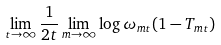<formula> <loc_0><loc_0><loc_500><loc_500>\lim _ { t \rightarrow \infty } \frac { 1 } { 2 t } \lim _ { m \rightarrow \infty } \log \omega _ { m t } ( 1 - T _ { m t } )</formula> 